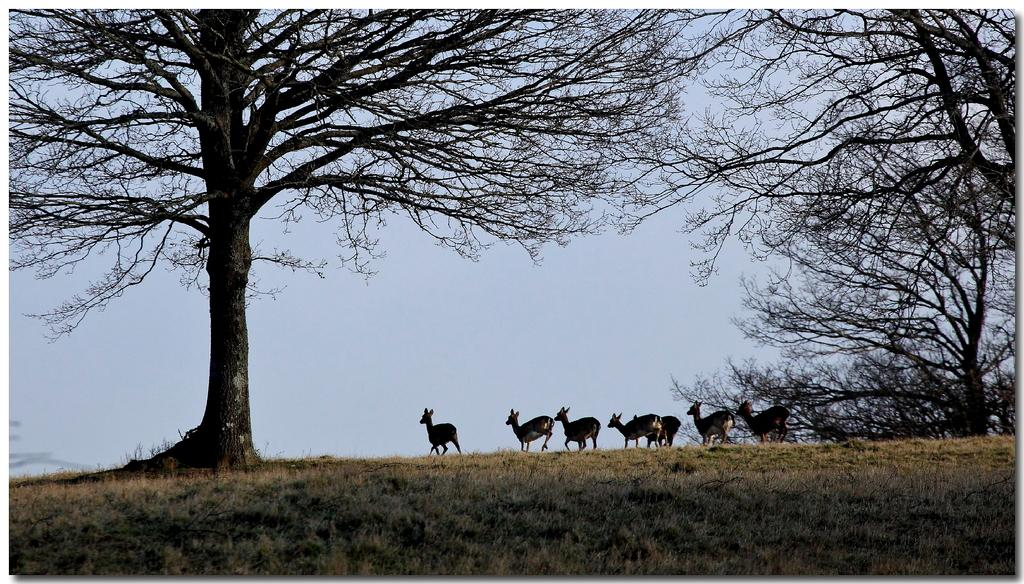What type of surface is on the ground in the image? There is grass on the ground in the image. What other living creatures can be seen in the image? There are animals visible in the image. What type of vegetation is present on the ground in the image? There are trees on the ground in the image. What can be seen in the distance in the image? The sky is visible in the background of the image. What type of paste is being used by the animals in the image? There is no paste present in the image; the animals are not engaged in any such activity. 